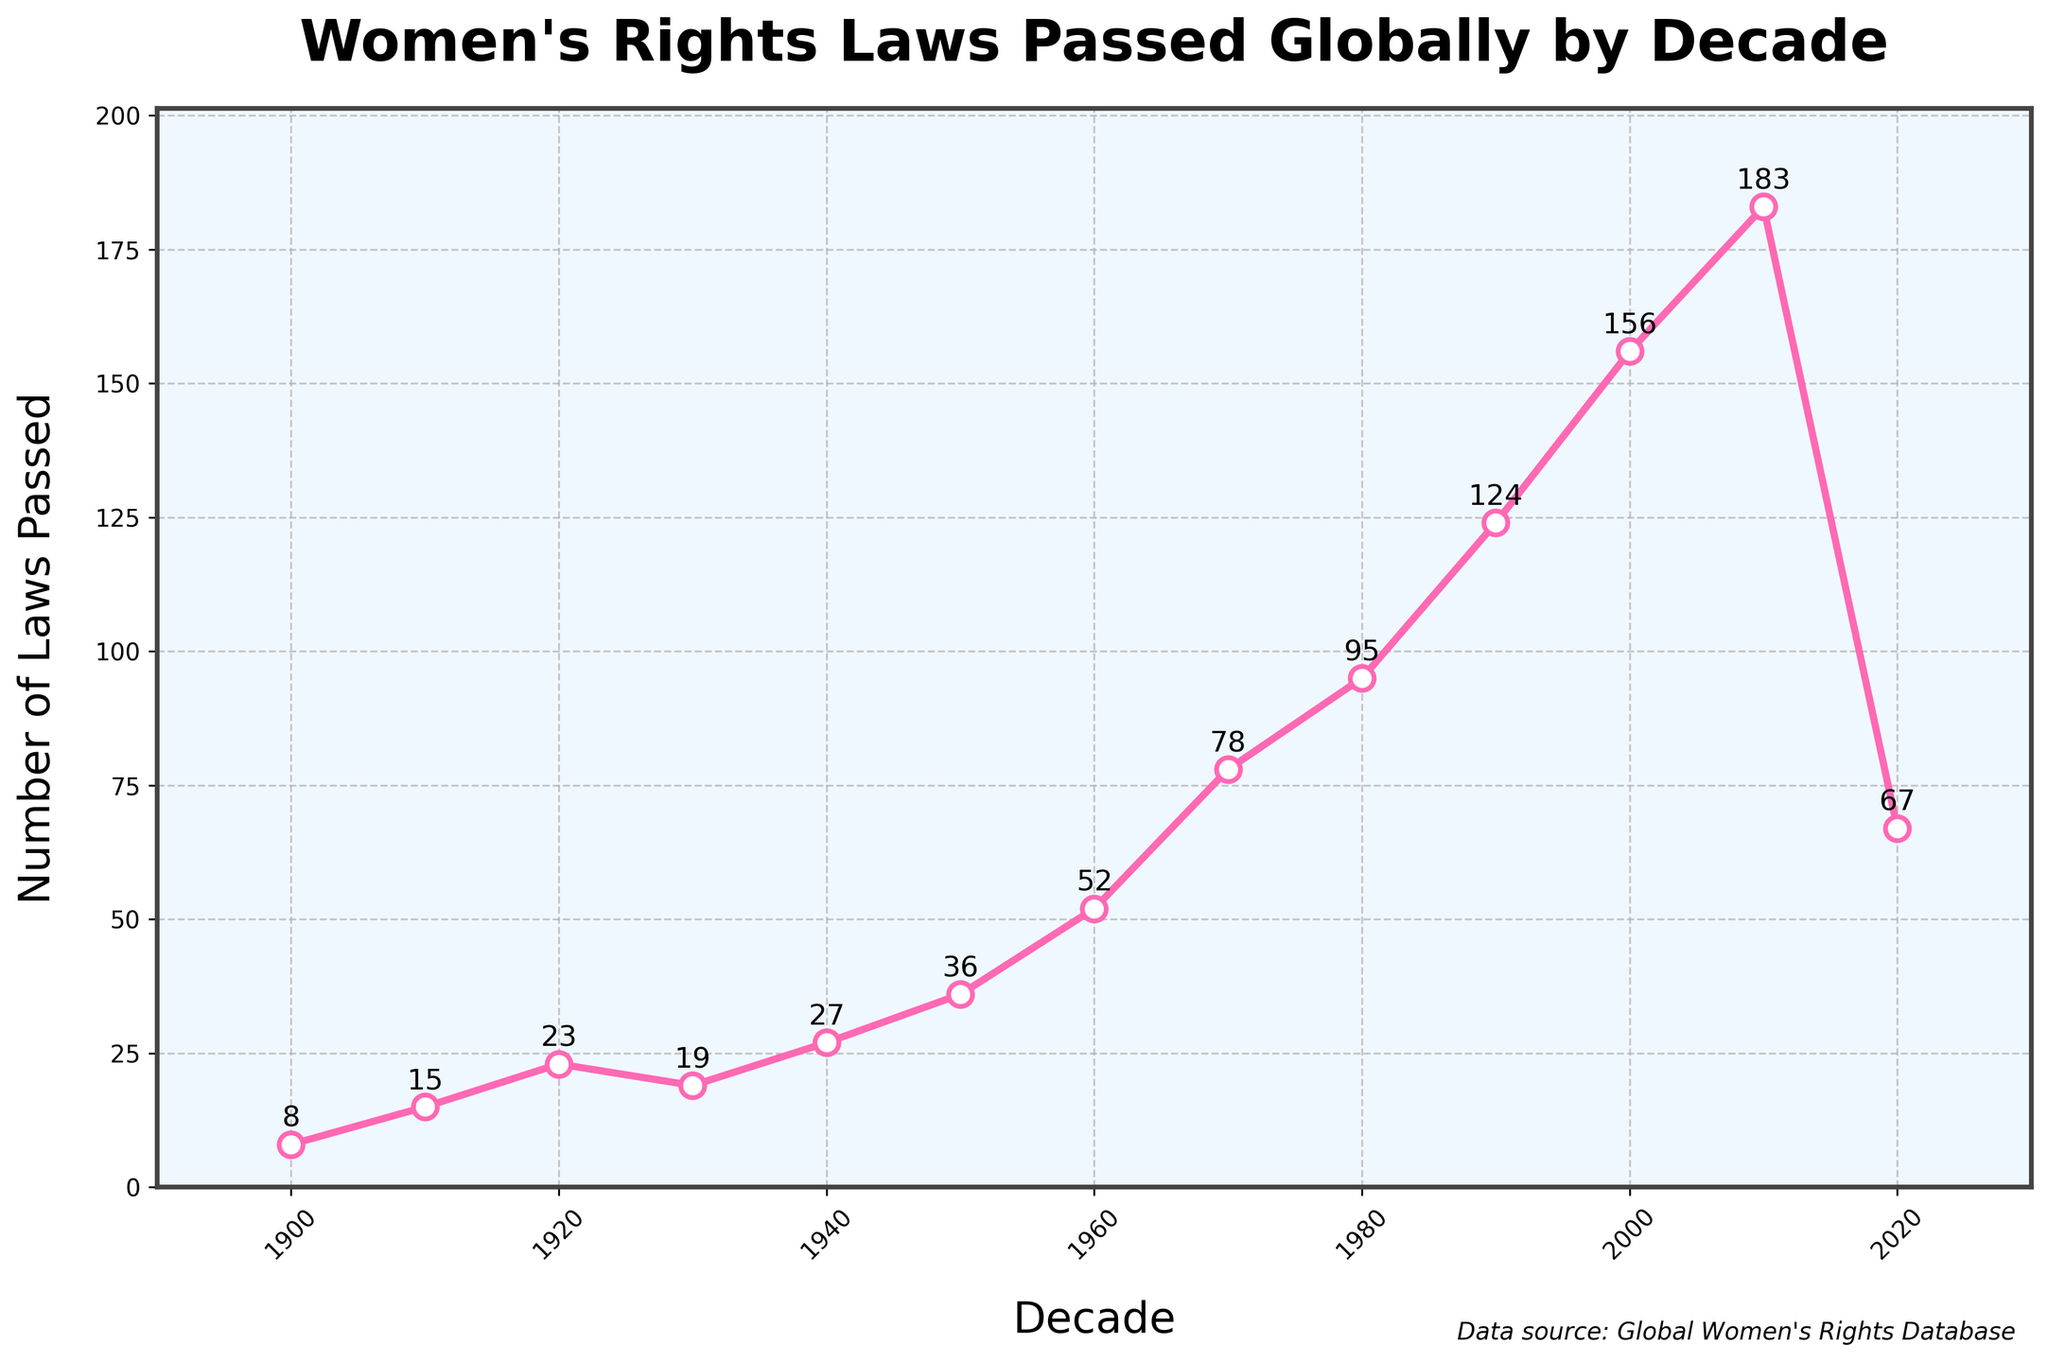Which decade saw the highest number of women's rights laws passed globally? Look at the peak point in the figure, which represents the highest number of laws passed in a decade. The 2010-2019 decade has the highest point at 183 laws.
Answer: 2010-2019 In which two decades did the number of women's rights laws passed globally approximately double compared to the previous decade? By examining the points, the number of laws increased from 15 (1910-1919) to 23 (1920-1929) and from 78 (1970-1979) to 95 (1980-1989). These show approximate doubling compared to their preceding decades.
Answer: 1920-1929 and 1980-1989 Calculate the total number of women's rights laws passed globally from 1900 to 1949. Sum the values for the decades 1900-1909 (8), 1910-1919 (15), 1920-1929 (23), 1930-1939 (19), and 1940-1949 (27): 8 + 15 + 23 + 19 + 27 = 92.
Answer: 92 In which decade did the number of women's rights laws passed globally first exceed 100? Identify the first point where the number of laws passed is above 100. This occurs in the 1990-1999 decade with 124 laws passed.
Answer: 1990-1999 What is the trend of women's rights laws passed globally from 1900 to 2019? Observe the direction of the line from 1900 to 2019. The trend is an overall increase, as the number of laws passed rises significantly from 8 to 183.
Answer: Increasing Compare the number of women's rights laws passed globally in 1910-1919 and 2020-2029. By how much did it change? In 1910-1919, 15 laws were passed. In 2020-2029, 67 laws were passed. The change is 67 - 15 = 52.
Answer: Increased by 52 Which decade experienced the most significant growth in the number of women's rights laws passed globally compared to its previous decade? Calculate the differences between consecutive decades and find the maximum. From 2000-2009 to 2010-2019, the increase is 183 - 156 = 27, which is the highest.
Answer: 2010-2019 What visual aspect of the chart emphasizes the increase in women's rights laws passed globally over time? The line in the chart rises consistently, marked with large dots that highlight the values for each decade. Additionally, the increasing height of the points shows the growth visually.
Answer: Rising line with large dots 